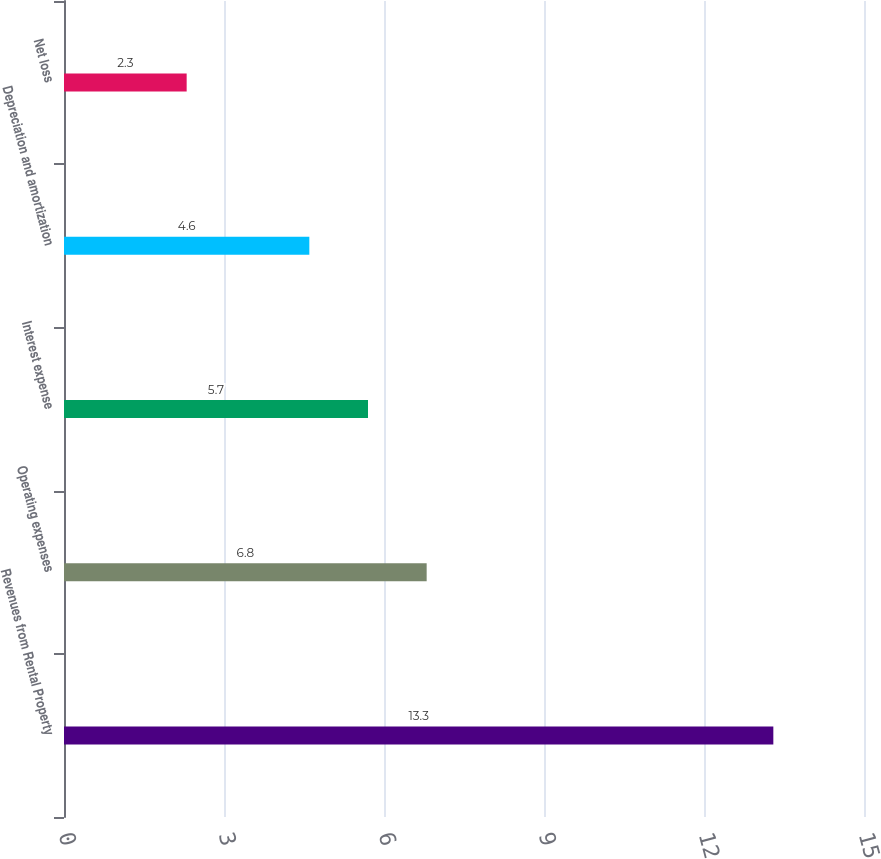Convert chart to OTSL. <chart><loc_0><loc_0><loc_500><loc_500><bar_chart><fcel>Revenues from Rental Property<fcel>Operating expenses<fcel>Interest expense<fcel>Depreciation and amortization<fcel>Net loss<nl><fcel>13.3<fcel>6.8<fcel>5.7<fcel>4.6<fcel>2.3<nl></chart> 